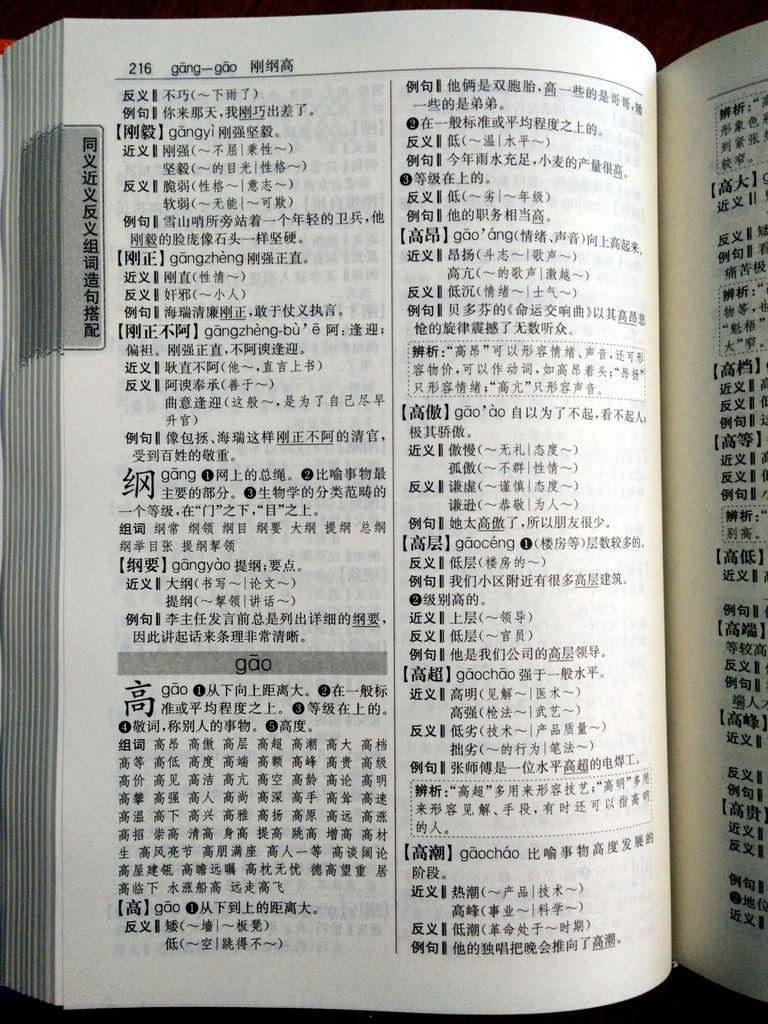<image>
Create a compact narrative representing the image presented. A book written in Chinese is open to page 216 